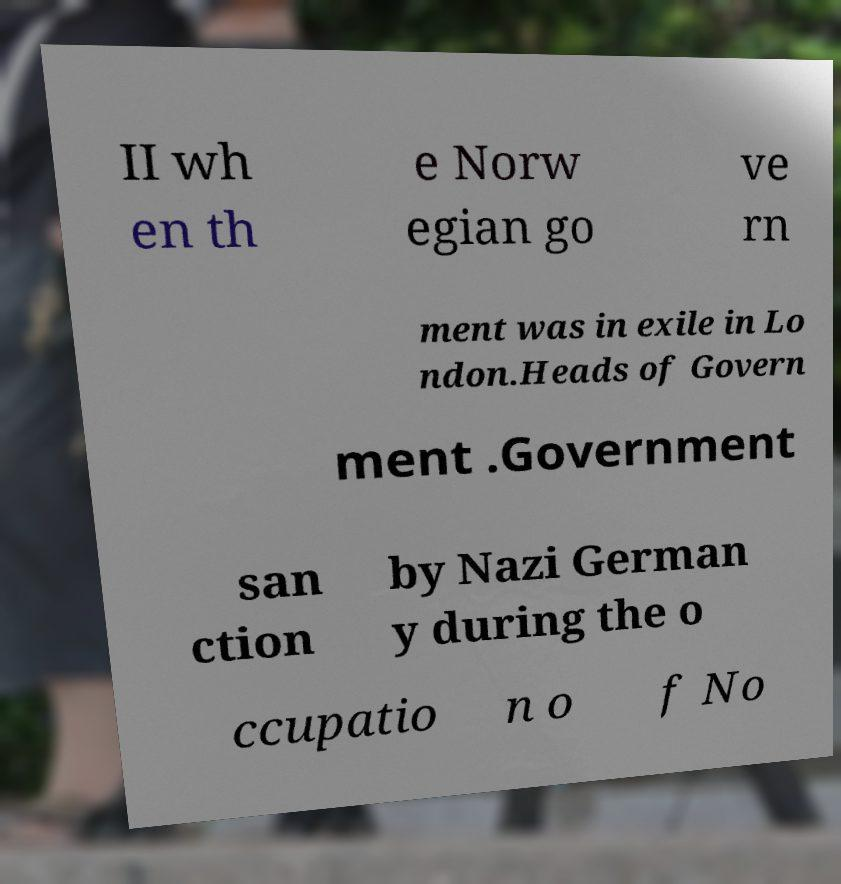Please read and relay the text visible in this image. What does it say? II wh en th e Norw egian go ve rn ment was in exile in Lo ndon.Heads of Govern ment .Government san ction by Nazi German y during the o ccupatio n o f No 